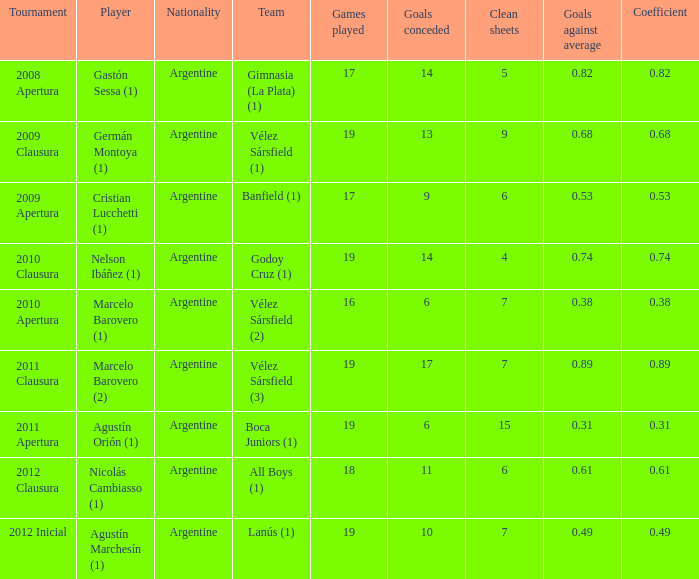 the 2010 clausura tournament? 0.74. 